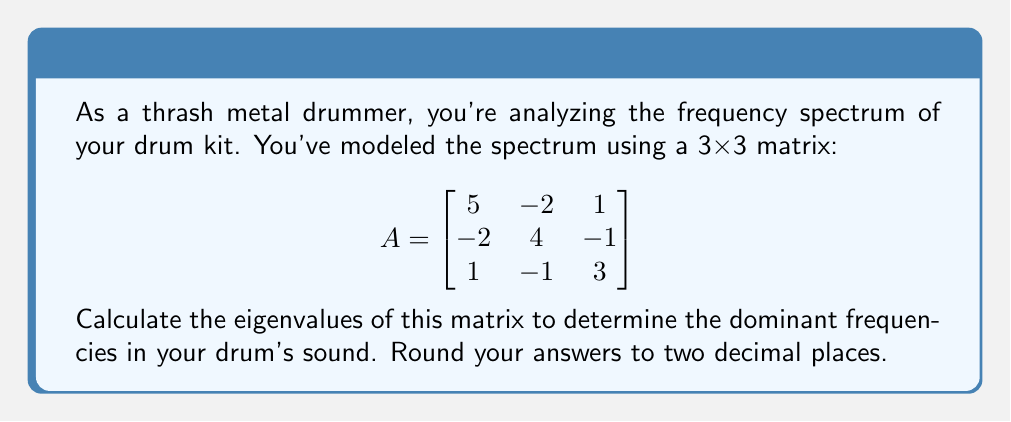Can you solve this math problem? To find the eigenvalues of matrix A, we need to solve the characteristic equation:

1) First, we set up the equation $det(A - \lambda I) = 0$, where $\lambda$ represents the eigenvalues:

$$det\begin{pmatrix}
5-\lambda & -2 & 1 \\
-2 & 4-\lambda & -1 \\
1 & -1 & 3-\lambda
\end{pmatrix} = 0$$

2) Expand the determinant:

$(5-\lambda)[(4-\lambda)(3-\lambda) - (-1)(-1)] + (-2)[(-2)(3-\lambda) - 1(1)] + 1[(-2)(-1) - (4-\lambda)(1)] = 0$

3) Simplify:

$(5-\lambda)[(12-7\lambda+\lambda^2) - 1] + (-2)[-6+2\lambda - 1] + 1[2 - (4-\lambda)] = 0$

4) Expand further:

$(5-\lambda)(11-7\lambda+\lambda^2) + (-2)(-7+2\lambda) + 1(-2+\lambda) = 0$

5) Multiply out:

$55-35\lambda+5\lambda^2-11\lambda+7\lambda^2-\lambda^3 + 14-4\lambda - 2 + \lambda = 0$

6) Collect like terms:

$-\lambda^3 + 12\lambda^2 - 39\lambda + 67 = 0$

7) This is our characteristic polynomial. To solve it, we can use a calculator or computer algebra system. The roots of this polynomial are the eigenvalues.

8) Solving this equation gives us the eigenvalues (rounded to two decimal places):

$\lambda_1 \approx 7.27$
$\lambda_2 \approx 3.31$
$\lambda_3 \approx 1.42$
Answer: $\lambda_1 \approx 7.27$, $\lambda_2 \approx 3.31$, $\lambda_3 \approx 1.42$ 